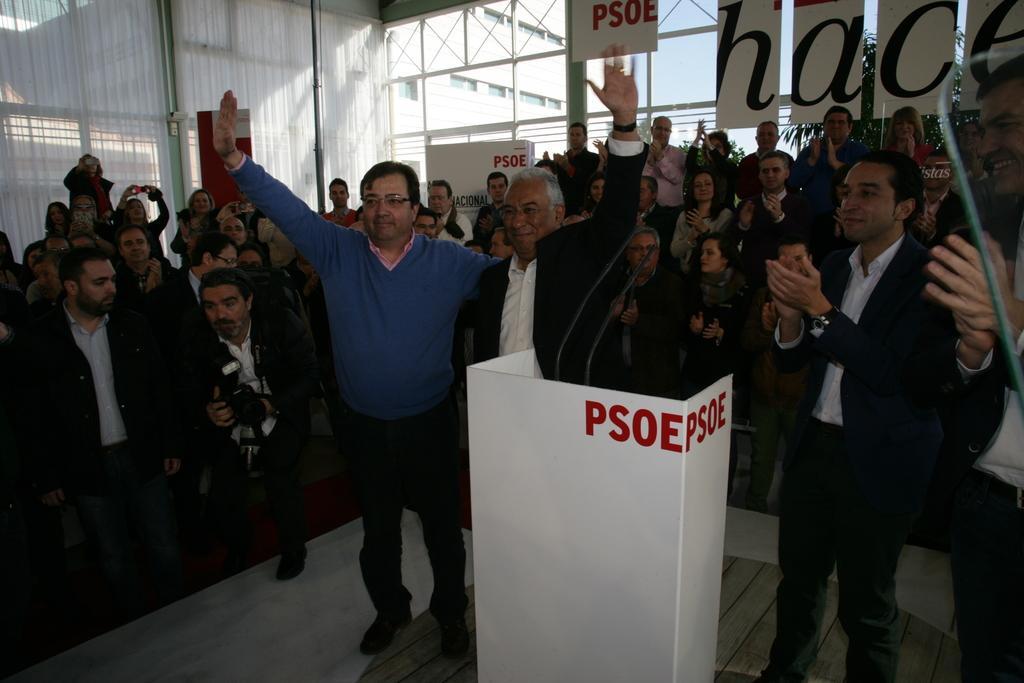Please provide a concise description of this image. In the center of the image there is a podium. There are two people standing and raising their hands. In the background of the image there are people, boards with some text and rods. To the left side of the image there is wall. At the bottom of the image there is floor. 